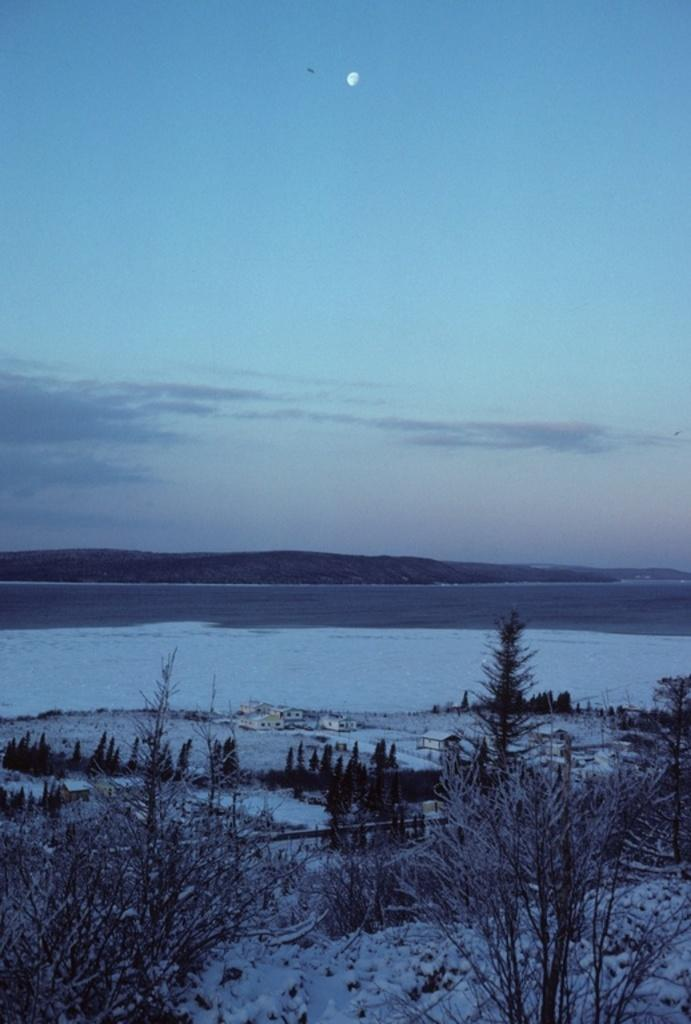What is the primary subject of the image? There are many plants in the image. What is the ground made of in the image? There is snow at the bottom of the image. What can be seen in the middle of the image? There is water visible in the middle of the image. What is visible at the top of the image? There is sky at the top of the image. What type of rhythm can be heard coming from the plants in the image? There is no sound or rhythm associated with the plants in the image. 